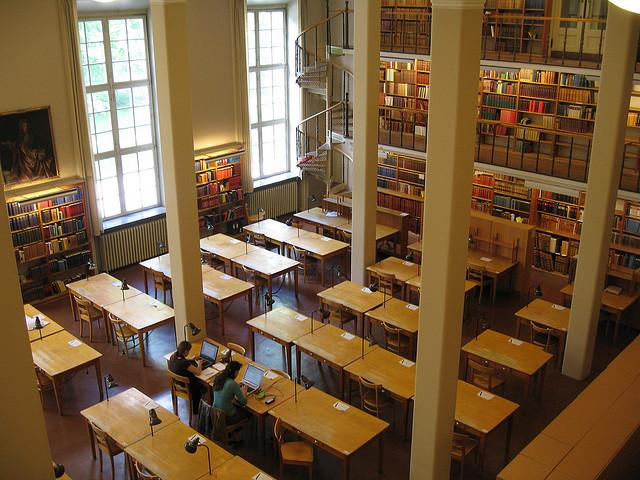What is located in the corner?

Choices:
A) trash
B) couch
C) stairs
D) lamp stairs 